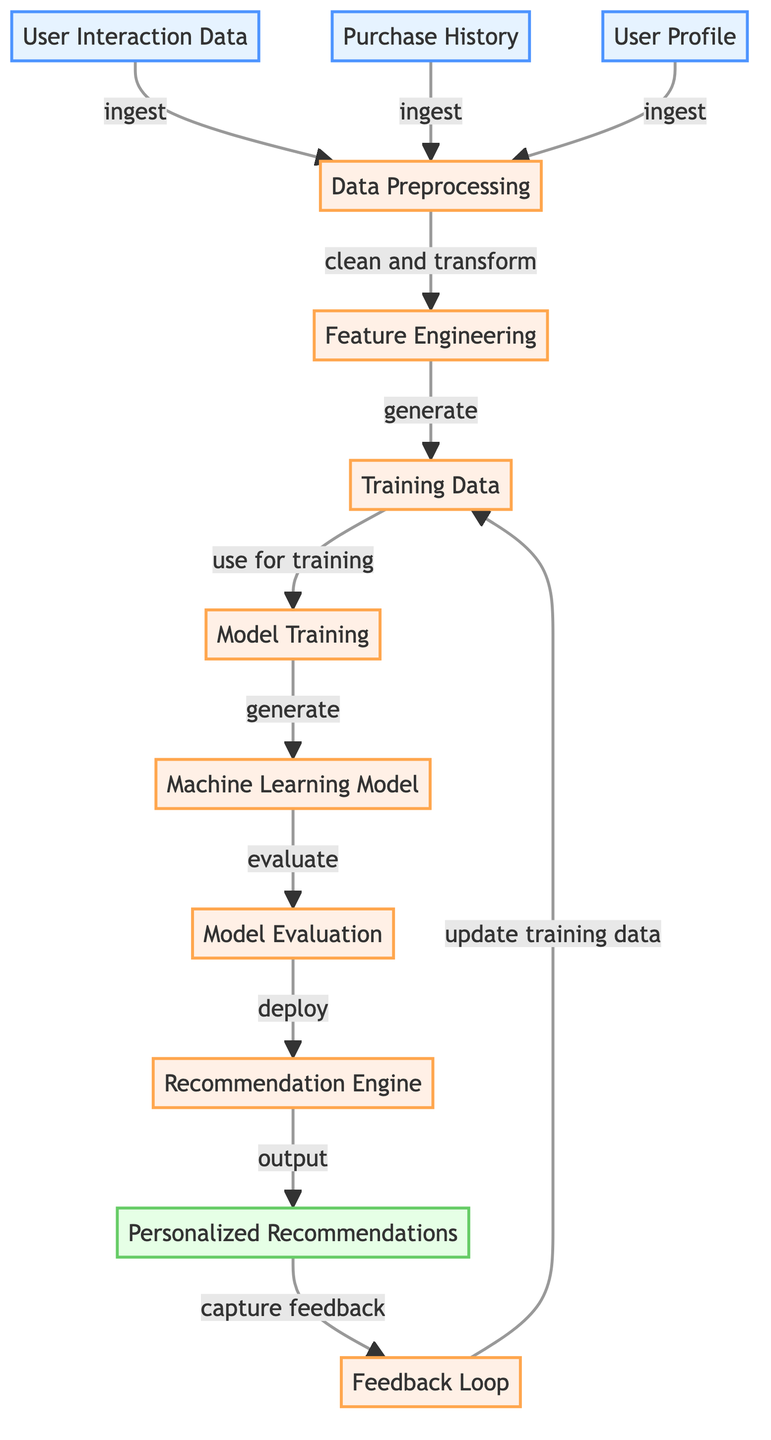What is the input node that represents User Interaction Data? In the given diagram, the node labeled "User Interaction Data" is classified as an input node. It is the first node in the flowchart and directly represents the data that is input into the process.
Answer: User Interaction Data How many input nodes are present in the diagram? The diagram contains three input nodes: "User Interaction Data," "Purchase History," and "User Profile." By counting each of these nodes, we find a total of three input nodes.
Answer: 3 What is the purpose of the Data Preprocessing node? The Data Preprocessing node is the first process in the diagram that takes input from all user data and prepares it for further processing. It is responsible for cleaning and transforming this data to make it suitable for feature engineering.
Answer: Clean and transform What output is generated by the Recommendation Engine? The Recommendation Engine processes the training data after model evaluation and deployment, ultimately generating personalized recommendations based on the user's behavior and preferences as captured in the model.
Answer: Personalized Recommendations Which node captures user feedback? The node labeled "Feedback Loop" serves to capture feedback from the personalized recommendations. This feedback is crucial for refining and improving the model over time.
Answer: Feedback Loop How does the training data get updated in the diagram? The process begins with feedback collected in the Feedback Loop, which then updates the training data in the Feature Engineering node. This cyclical process ensures the model learns and adapts over time based on user interactions.
Answer: Update training data What is the relationship between Model Evaluation and Recommendation Engine? There is a direct path shown in the diagram from Model Evaluation to Recommendation Engine, indicating that once the model is evaluated, it proceeds to the Recommendation Engine for generating recommendations.
Answer: Deploy Which node is responsible for generating training data? The node labeled "Feature Engineering" is where training data is generated. It acts as a bridge between the cleaned data from preprocessing and the actual machine learning model training.
Answer: Feature Engineering How many processes are in the flowchart? The flowchart features six process nodes, namely Data Preprocessing, Feature Engineering, Training Data, Machine Learning Model, Model Training, and Model Evaluation. This total is determined by counting each process node in the diagram.
Answer: 6 